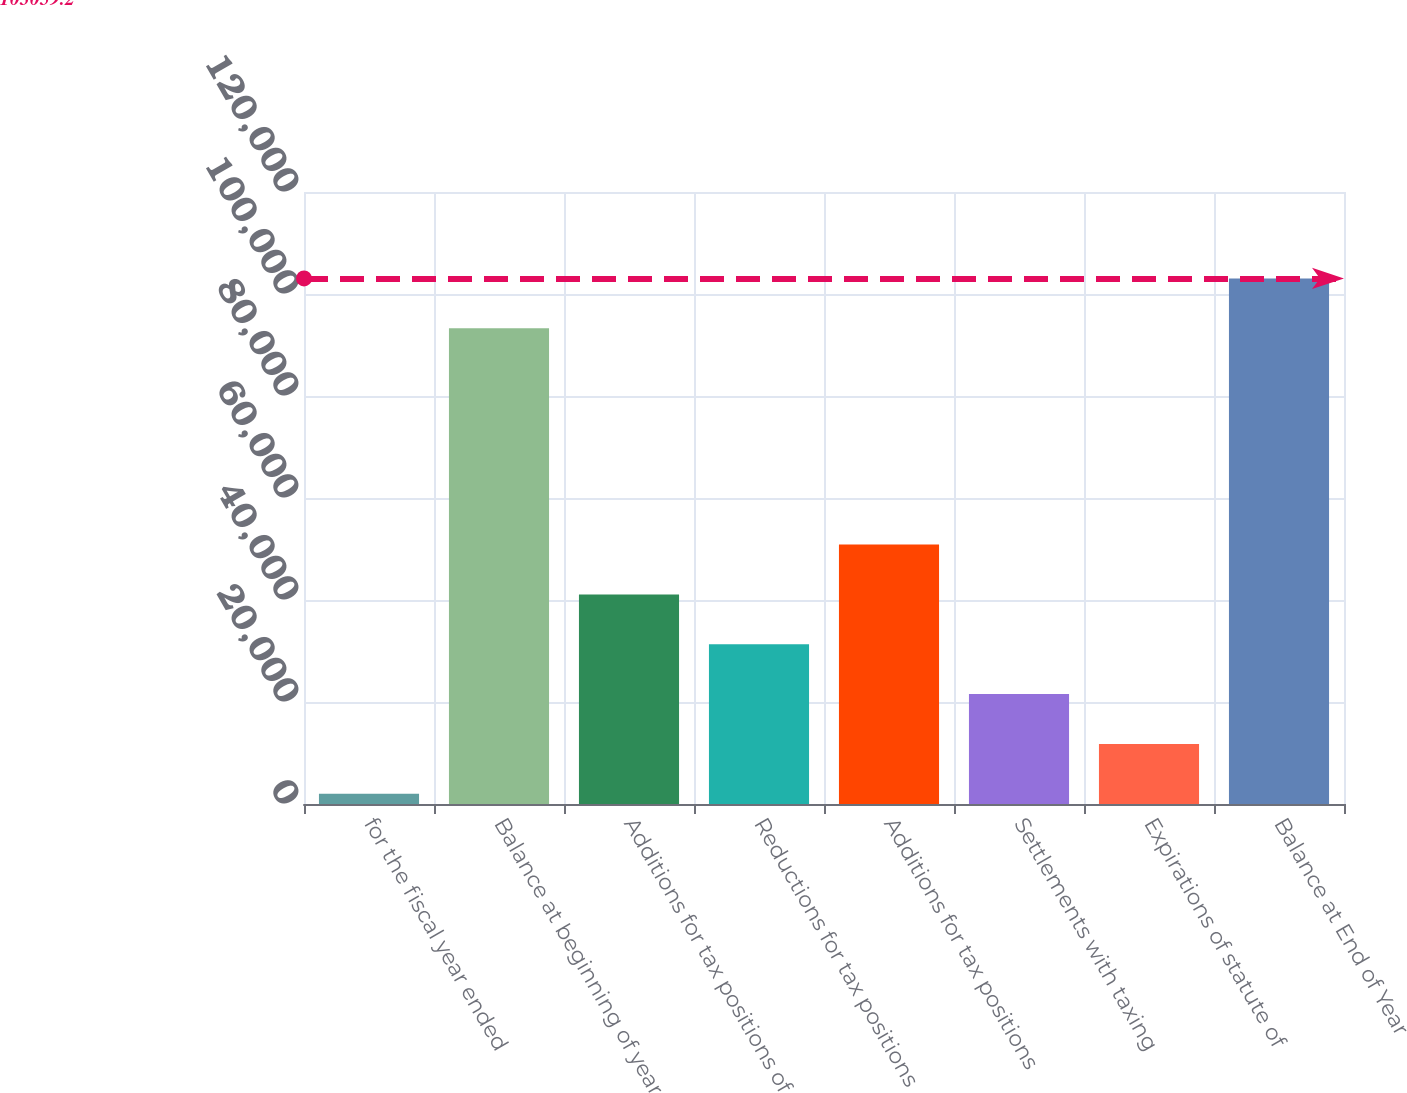Convert chart to OTSL. <chart><loc_0><loc_0><loc_500><loc_500><bar_chart><fcel>for the fiscal year ended<fcel>Balance at beginning of year<fcel>Additions for tax positions of<fcel>Reductions for tax positions<fcel>Additions for tax positions<fcel>Settlements with taxing<fcel>Expirations of statute of<fcel>Balance at End of Year<nl><fcel>2011<fcel>93288<fcel>41095.8<fcel>31324.6<fcel>50867<fcel>21553.4<fcel>11782.2<fcel>103059<nl></chart> 